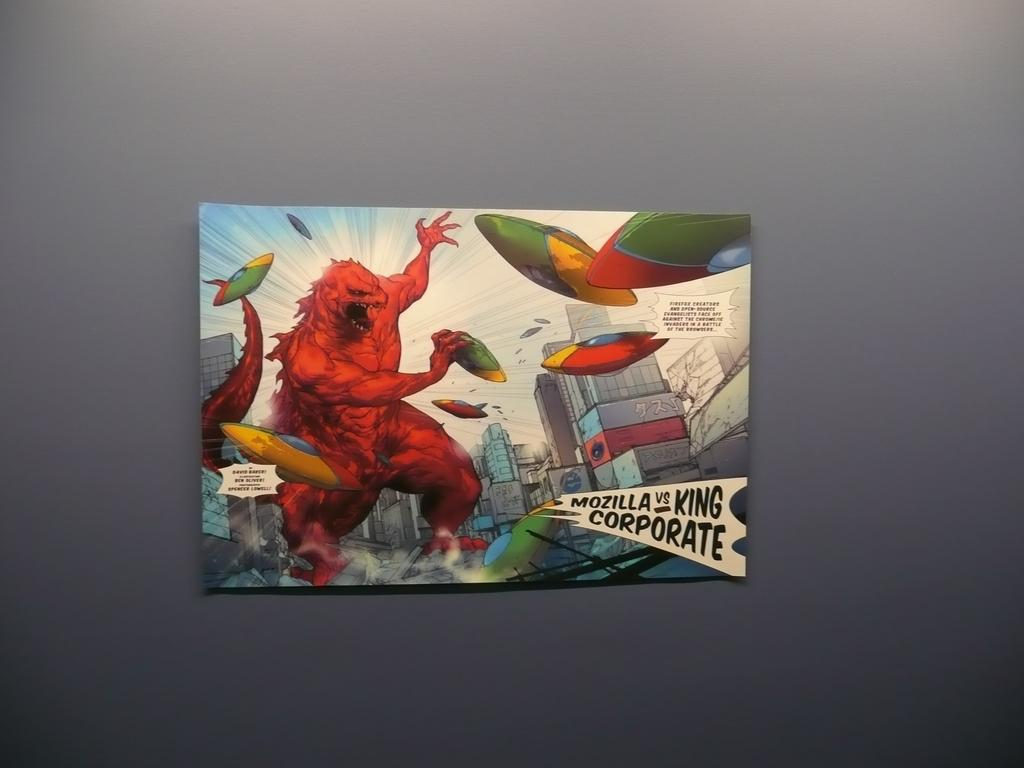<image>
Present a compact description of the photo's key features. A painting of depicting Mozilla as a comic book monster 